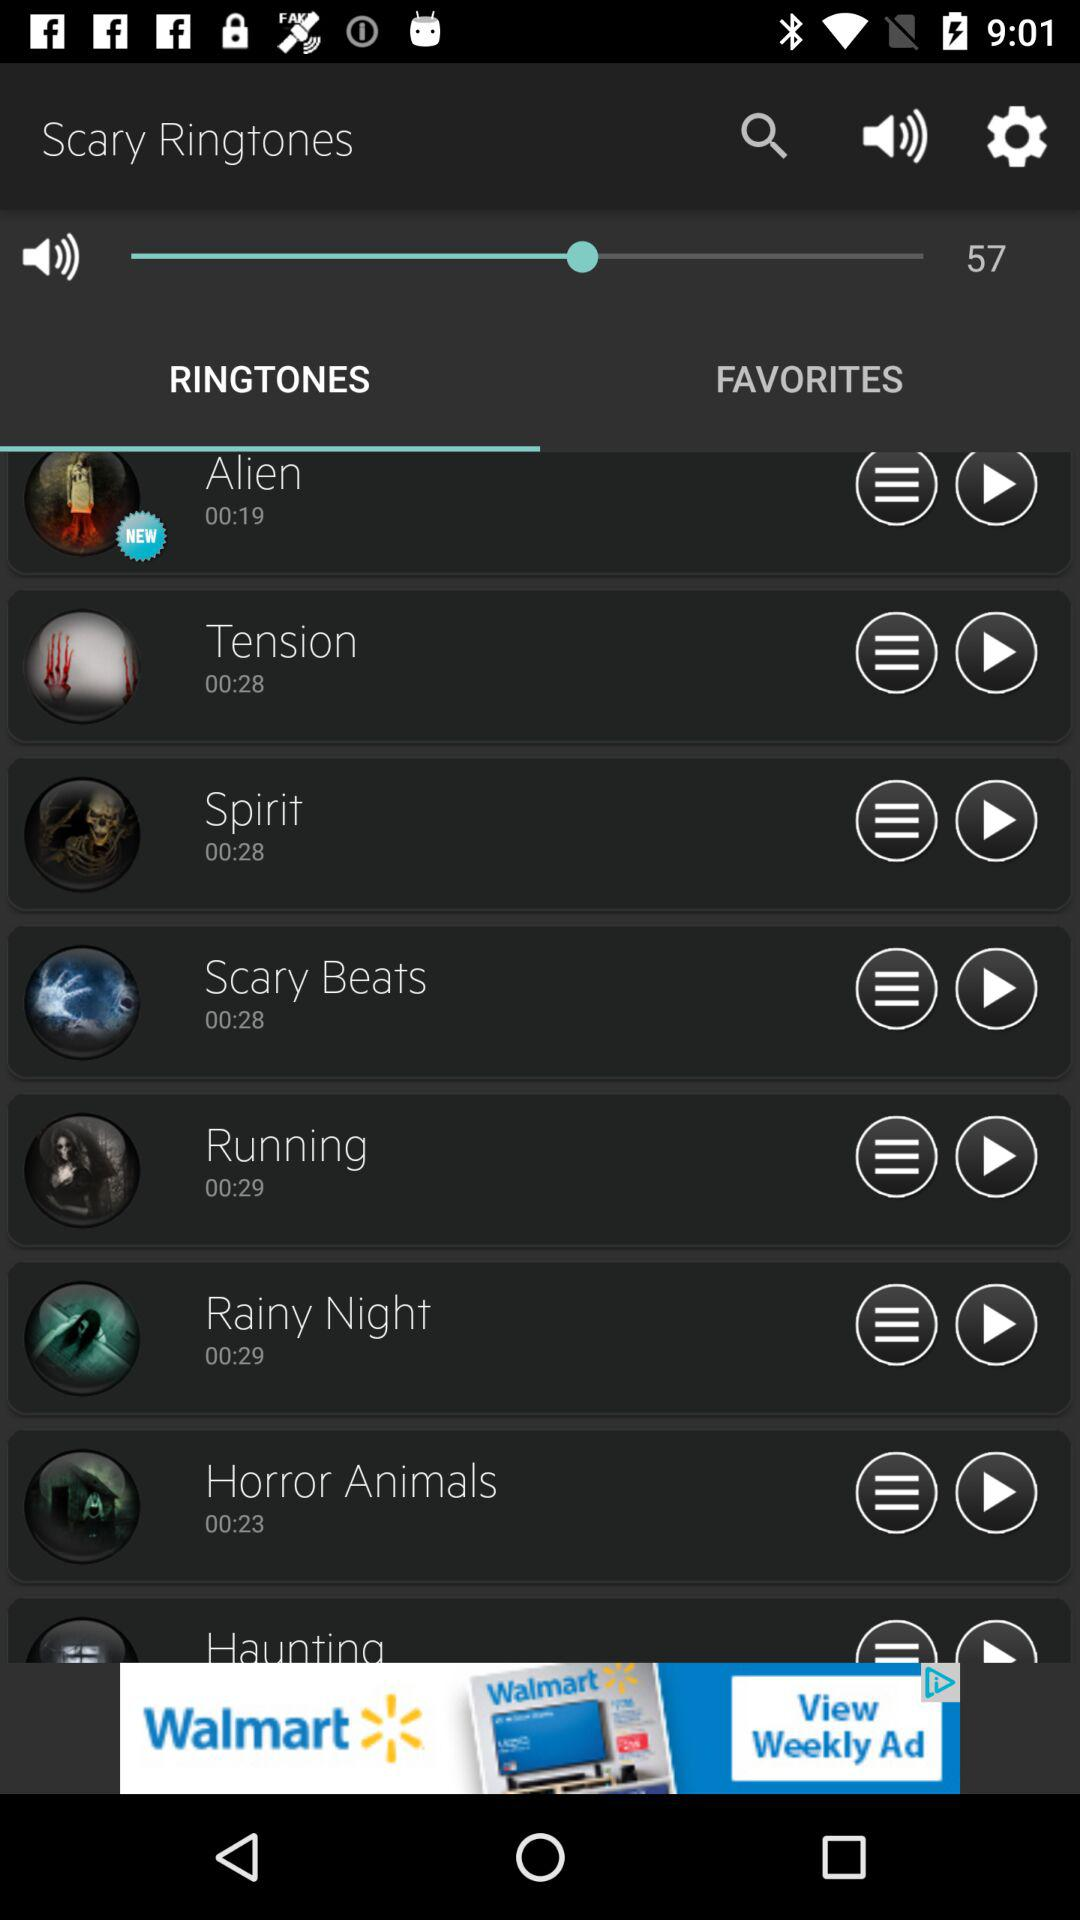Which tab is selected? The selected tab is "RINGTONES". 